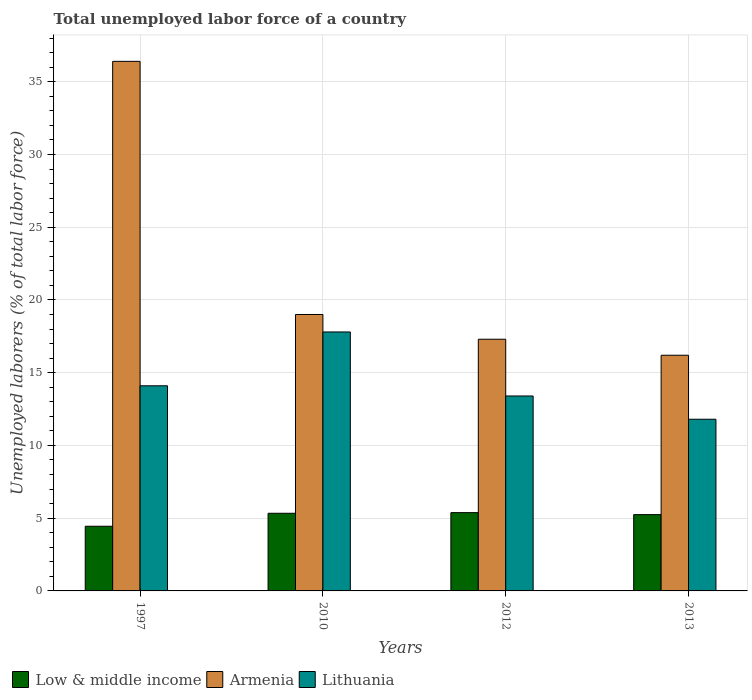How many groups of bars are there?
Offer a terse response. 4. Are the number of bars on each tick of the X-axis equal?
Keep it short and to the point. Yes. How many bars are there on the 2nd tick from the left?
Offer a terse response. 3. How many bars are there on the 3rd tick from the right?
Your response must be concise. 3. In how many cases, is the number of bars for a given year not equal to the number of legend labels?
Make the answer very short. 0. Across all years, what is the maximum total unemployed labor force in Low & middle income?
Provide a short and direct response. 5.38. Across all years, what is the minimum total unemployed labor force in Low & middle income?
Your answer should be compact. 4.45. In which year was the total unemployed labor force in Lithuania maximum?
Give a very brief answer. 2010. In which year was the total unemployed labor force in Lithuania minimum?
Offer a terse response. 2013. What is the total total unemployed labor force in Low & middle income in the graph?
Your answer should be very brief. 20.41. What is the difference between the total unemployed labor force in Low & middle income in 1997 and that in 2010?
Offer a very short reply. -0.89. What is the difference between the total unemployed labor force in Lithuania in 2012 and the total unemployed labor force in Low & middle income in 2013?
Give a very brief answer. 8.16. What is the average total unemployed labor force in Armenia per year?
Your response must be concise. 22.23. In the year 2013, what is the difference between the total unemployed labor force in Armenia and total unemployed labor force in Low & middle income?
Your response must be concise. 10.96. In how many years, is the total unemployed labor force in Low & middle income greater than 37 %?
Your answer should be very brief. 0. What is the ratio of the total unemployed labor force in Low & middle income in 1997 to that in 2010?
Your answer should be very brief. 0.83. What is the difference between the highest and the second highest total unemployed labor force in Low & middle income?
Keep it short and to the point. 0.04. What is the difference between the highest and the lowest total unemployed labor force in Low & middle income?
Offer a very short reply. 0.93. In how many years, is the total unemployed labor force in Armenia greater than the average total unemployed labor force in Armenia taken over all years?
Give a very brief answer. 1. Is the sum of the total unemployed labor force in Armenia in 1997 and 2013 greater than the maximum total unemployed labor force in Lithuania across all years?
Offer a very short reply. Yes. What does the 2nd bar from the left in 2013 represents?
Provide a succinct answer. Armenia. What does the 1st bar from the right in 1997 represents?
Make the answer very short. Lithuania. Is it the case that in every year, the sum of the total unemployed labor force in Low & middle income and total unemployed labor force in Armenia is greater than the total unemployed labor force in Lithuania?
Offer a terse response. Yes. Are all the bars in the graph horizontal?
Offer a terse response. No. How many years are there in the graph?
Provide a succinct answer. 4. What is the difference between two consecutive major ticks on the Y-axis?
Offer a very short reply. 5. Does the graph contain grids?
Keep it short and to the point. Yes. What is the title of the graph?
Your answer should be very brief. Total unemployed labor force of a country. Does "Yemen, Rep." appear as one of the legend labels in the graph?
Provide a short and direct response. No. What is the label or title of the X-axis?
Provide a short and direct response. Years. What is the label or title of the Y-axis?
Provide a succinct answer. Unemployed laborers (% of total labor force). What is the Unemployed laborers (% of total labor force) of Low & middle income in 1997?
Your answer should be compact. 4.45. What is the Unemployed laborers (% of total labor force) of Armenia in 1997?
Your response must be concise. 36.4. What is the Unemployed laborers (% of total labor force) in Lithuania in 1997?
Your answer should be compact. 14.1. What is the Unemployed laborers (% of total labor force) in Low & middle income in 2010?
Your answer should be compact. 5.34. What is the Unemployed laborers (% of total labor force) of Armenia in 2010?
Your response must be concise. 19. What is the Unemployed laborers (% of total labor force) in Lithuania in 2010?
Offer a terse response. 17.8. What is the Unemployed laborers (% of total labor force) of Low & middle income in 2012?
Keep it short and to the point. 5.38. What is the Unemployed laborers (% of total labor force) of Armenia in 2012?
Keep it short and to the point. 17.3. What is the Unemployed laborers (% of total labor force) of Lithuania in 2012?
Make the answer very short. 13.4. What is the Unemployed laborers (% of total labor force) of Low & middle income in 2013?
Offer a very short reply. 5.24. What is the Unemployed laborers (% of total labor force) in Armenia in 2013?
Keep it short and to the point. 16.2. What is the Unemployed laborers (% of total labor force) of Lithuania in 2013?
Give a very brief answer. 11.8. Across all years, what is the maximum Unemployed laborers (% of total labor force) in Low & middle income?
Provide a succinct answer. 5.38. Across all years, what is the maximum Unemployed laborers (% of total labor force) in Armenia?
Ensure brevity in your answer.  36.4. Across all years, what is the maximum Unemployed laborers (% of total labor force) of Lithuania?
Offer a very short reply. 17.8. Across all years, what is the minimum Unemployed laborers (% of total labor force) of Low & middle income?
Give a very brief answer. 4.45. Across all years, what is the minimum Unemployed laborers (% of total labor force) of Armenia?
Give a very brief answer. 16.2. Across all years, what is the minimum Unemployed laborers (% of total labor force) of Lithuania?
Keep it short and to the point. 11.8. What is the total Unemployed laborers (% of total labor force) in Low & middle income in the graph?
Make the answer very short. 20.41. What is the total Unemployed laborers (% of total labor force) in Armenia in the graph?
Your response must be concise. 88.9. What is the total Unemployed laborers (% of total labor force) in Lithuania in the graph?
Offer a very short reply. 57.1. What is the difference between the Unemployed laborers (% of total labor force) of Low & middle income in 1997 and that in 2010?
Give a very brief answer. -0.89. What is the difference between the Unemployed laborers (% of total labor force) of Armenia in 1997 and that in 2010?
Your response must be concise. 17.4. What is the difference between the Unemployed laborers (% of total labor force) of Low & middle income in 1997 and that in 2012?
Give a very brief answer. -0.93. What is the difference between the Unemployed laborers (% of total labor force) of Armenia in 1997 and that in 2012?
Your answer should be compact. 19.1. What is the difference between the Unemployed laborers (% of total labor force) of Low & middle income in 1997 and that in 2013?
Offer a very short reply. -0.8. What is the difference between the Unemployed laborers (% of total labor force) in Armenia in 1997 and that in 2013?
Your answer should be very brief. 20.2. What is the difference between the Unemployed laborers (% of total labor force) in Low & middle income in 2010 and that in 2012?
Offer a very short reply. -0.04. What is the difference between the Unemployed laborers (% of total labor force) in Low & middle income in 2010 and that in 2013?
Offer a very short reply. 0.09. What is the difference between the Unemployed laborers (% of total labor force) of Armenia in 2010 and that in 2013?
Offer a terse response. 2.8. What is the difference between the Unemployed laborers (% of total labor force) in Low & middle income in 2012 and that in 2013?
Your answer should be very brief. 0.14. What is the difference between the Unemployed laborers (% of total labor force) in Armenia in 2012 and that in 2013?
Provide a succinct answer. 1.1. What is the difference between the Unemployed laborers (% of total labor force) in Low & middle income in 1997 and the Unemployed laborers (% of total labor force) in Armenia in 2010?
Make the answer very short. -14.55. What is the difference between the Unemployed laborers (% of total labor force) in Low & middle income in 1997 and the Unemployed laborers (% of total labor force) in Lithuania in 2010?
Make the answer very short. -13.35. What is the difference between the Unemployed laborers (% of total labor force) in Low & middle income in 1997 and the Unemployed laborers (% of total labor force) in Armenia in 2012?
Ensure brevity in your answer.  -12.85. What is the difference between the Unemployed laborers (% of total labor force) of Low & middle income in 1997 and the Unemployed laborers (% of total labor force) of Lithuania in 2012?
Keep it short and to the point. -8.95. What is the difference between the Unemployed laborers (% of total labor force) in Armenia in 1997 and the Unemployed laborers (% of total labor force) in Lithuania in 2012?
Give a very brief answer. 23. What is the difference between the Unemployed laborers (% of total labor force) of Low & middle income in 1997 and the Unemployed laborers (% of total labor force) of Armenia in 2013?
Provide a short and direct response. -11.75. What is the difference between the Unemployed laborers (% of total labor force) of Low & middle income in 1997 and the Unemployed laborers (% of total labor force) of Lithuania in 2013?
Offer a very short reply. -7.35. What is the difference between the Unemployed laborers (% of total labor force) in Armenia in 1997 and the Unemployed laborers (% of total labor force) in Lithuania in 2013?
Provide a succinct answer. 24.6. What is the difference between the Unemployed laborers (% of total labor force) of Low & middle income in 2010 and the Unemployed laborers (% of total labor force) of Armenia in 2012?
Give a very brief answer. -11.96. What is the difference between the Unemployed laborers (% of total labor force) of Low & middle income in 2010 and the Unemployed laborers (% of total labor force) of Lithuania in 2012?
Offer a very short reply. -8.06. What is the difference between the Unemployed laborers (% of total labor force) of Armenia in 2010 and the Unemployed laborers (% of total labor force) of Lithuania in 2012?
Provide a succinct answer. 5.6. What is the difference between the Unemployed laborers (% of total labor force) of Low & middle income in 2010 and the Unemployed laborers (% of total labor force) of Armenia in 2013?
Your answer should be compact. -10.86. What is the difference between the Unemployed laborers (% of total labor force) of Low & middle income in 2010 and the Unemployed laborers (% of total labor force) of Lithuania in 2013?
Provide a succinct answer. -6.46. What is the difference between the Unemployed laborers (% of total labor force) of Low & middle income in 2012 and the Unemployed laborers (% of total labor force) of Armenia in 2013?
Your answer should be compact. -10.82. What is the difference between the Unemployed laborers (% of total labor force) of Low & middle income in 2012 and the Unemployed laborers (% of total labor force) of Lithuania in 2013?
Ensure brevity in your answer.  -6.42. What is the difference between the Unemployed laborers (% of total labor force) in Armenia in 2012 and the Unemployed laborers (% of total labor force) in Lithuania in 2013?
Offer a terse response. 5.5. What is the average Unemployed laborers (% of total labor force) in Low & middle income per year?
Your answer should be very brief. 5.1. What is the average Unemployed laborers (% of total labor force) of Armenia per year?
Your response must be concise. 22.23. What is the average Unemployed laborers (% of total labor force) in Lithuania per year?
Offer a very short reply. 14.28. In the year 1997, what is the difference between the Unemployed laborers (% of total labor force) of Low & middle income and Unemployed laborers (% of total labor force) of Armenia?
Your answer should be very brief. -31.95. In the year 1997, what is the difference between the Unemployed laborers (% of total labor force) of Low & middle income and Unemployed laborers (% of total labor force) of Lithuania?
Provide a short and direct response. -9.65. In the year 1997, what is the difference between the Unemployed laborers (% of total labor force) of Armenia and Unemployed laborers (% of total labor force) of Lithuania?
Provide a succinct answer. 22.3. In the year 2010, what is the difference between the Unemployed laborers (% of total labor force) of Low & middle income and Unemployed laborers (% of total labor force) of Armenia?
Make the answer very short. -13.66. In the year 2010, what is the difference between the Unemployed laborers (% of total labor force) of Low & middle income and Unemployed laborers (% of total labor force) of Lithuania?
Your response must be concise. -12.46. In the year 2012, what is the difference between the Unemployed laborers (% of total labor force) of Low & middle income and Unemployed laborers (% of total labor force) of Armenia?
Keep it short and to the point. -11.92. In the year 2012, what is the difference between the Unemployed laborers (% of total labor force) of Low & middle income and Unemployed laborers (% of total labor force) of Lithuania?
Your response must be concise. -8.02. In the year 2013, what is the difference between the Unemployed laborers (% of total labor force) of Low & middle income and Unemployed laborers (% of total labor force) of Armenia?
Offer a terse response. -10.96. In the year 2013, what is the difference between the Unemployed laborers (% of total labor force) in Low & middle income and Unemployed laborers (% of total labor force) in Lithuania?
Make the answer very short. -6.55. What is the ratio of the Unemployed laborers (% of total labor force) in Low & middle income in 1997 to that in 2010?
Give a very brief answer. 0.83. What is the ratio of the Unemployed laborers (% of total labor force) in Armenia in 1997 to that in 2010?
Keep it short and to the point. 1.92. What is the ratio of the Unemployed laborers (% of total labor force) of Lithuania in 1997 to that in 2010?
Your answer should be very brief. 0.79. What is the ratio of the Unemployed laborers (% of total labor force) in Low & middle income in 1997 to that in 2012?
Provide a short and direct response. 0.83. What is the ratio of the Unemployed laborers (% of total labor force) in Armenia in 1997 to that in 2012?
Your response must be concise. 2.1. What is the ratio of the Unemployed laborers (% of total labor force) of Lithuania in 1997 to that in 2012?
Provide a short and direct response. 1.05. What is the ratio of the Unemployed laborers (% of total labor force) in Low & middle income in 1997 to that in 2013?
Ensure brevity in your answer.  0.85. What is the ratio of the Unemployed laborers (% of total labor force) of Armenia in 1997 to that in 2013?
Give a very brief answer. 2.25. What is the ratio of the Unemployed laborers (% of total labor force) in Lithuania in 1997 to that in 2013?
Offer a terse response. 1.19. What is the ratio of the Unemployed laborers (% of total labor force) of Armenia in 2010 to that in 2012?
Your answer should be compact. 1.1. What is the ratio of the Unemployed laborers (% of total labor force) in Lithuania in 2010 to that in 2012?
Your answer should be very brief. 1.33. What is the ratio of the Unemployed laborers (% of total labor force) in Low & middle income in 2010 to that in 2013?
Offer a terse response. 1.02. What is the ratio of the Unemployed laborers (% of total labor force) of Armenia in 2010 to that in 2013?
Give a very brief answer. 1.17. What is the ratio of the Unemployed laborers (% of total labor force) in Lithuania in 2010 to that in 2013?
Ensure brevity in your answer.  1.51. What is the ratio of the Unemployed laborers (% of total labor force) of Low & middle income in 2012 to that in 2013?
Ensure brevity in your answer.  1.03. What is the ratio of the Unemployed laborers (% of total labor force) of Armenia in 2012 to that in 2013?
Provide a short and direct response. 1.07. What is the ratio of the Unemployed laborers (% of total labor force) of Lithuania in 2012 to that in 2013?
Offer a terse response. 1.14. What is the difference between the highest and the second highest Unemployed laborers (% of total labor force) of Low & middle income?
Offer a very short reply. 0.04. What is the difference between the highest and the lowest Unemployed laborers (% of total labor force) of Low & middle income?
Make the answer very short. 0.93. What is the difference between the highest and the lowest Unemployed laborers (% of total labor force) in Armenia?
Offer a terse response. 20.2. What is the difference between the highest and the lowest Unemployed laborers (% of total labor force) in Lithuania?
Provide a short and direct response. 6. 